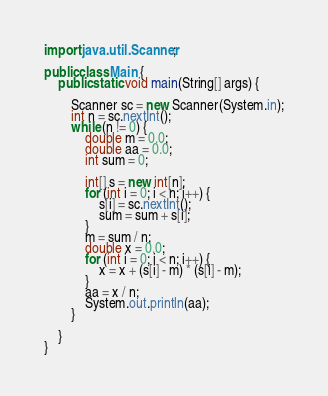Convert code to text. <code><loc_0><loc_0><loc_500><loc_500><_Java_>import java.util.Scanner;

public class Main {
	public static void main(String[] args) {

		Scanner sc = new Scanner(System.in);
		int n = sc.nextInt();
		while (n != 0) {
			double m = 0.0;
			double aa = 0.0;
			int sum = 0;

			int[] s = new int[n];
			for (int i = 0; i < n; i++) {
				s[i] = sc.nextInt();
				sum = sum + s[i];
			}
			m = sum / n;
			double x = 0.0;
			for (int i = 0; i < n; i++) {
				x = x + (s[i] - m) * (s[i] - m);
			}
			aa = x / n;
			System.out.println(aa);
		}

	}
}</code> 